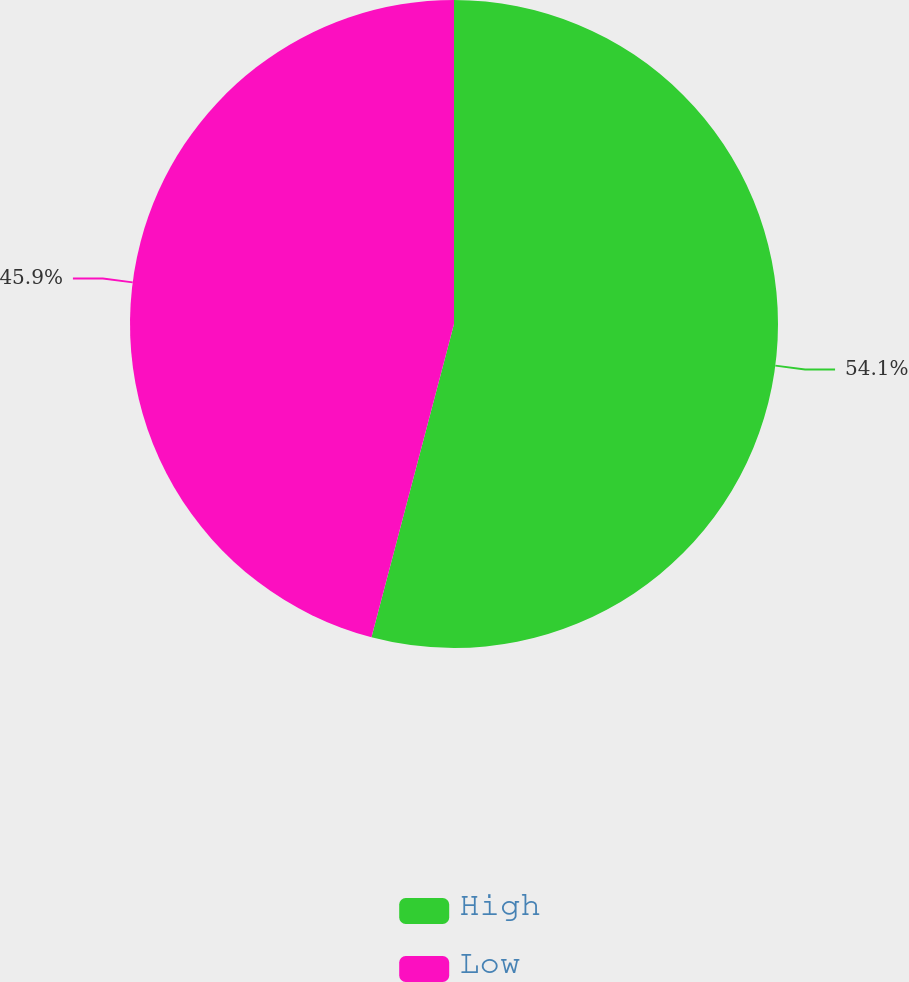Convert chart. <chart><loc_0><loc_0><loc_500><loc_500><pie_chart><fcel>High<fcel>Low<nl><fcel>54.1%<fcel>45.9%<nl></chart> 